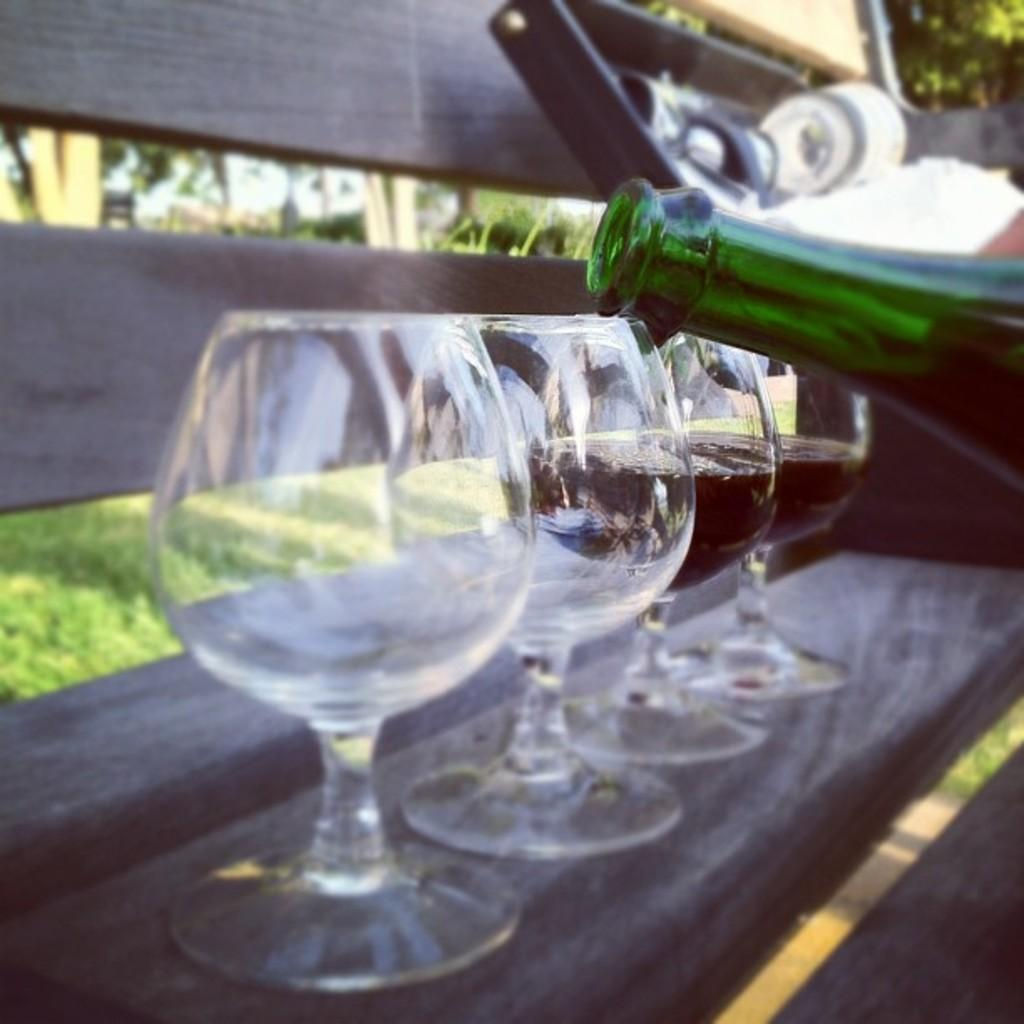What piece of furniture is present in the image? There is a table in the image. What is on the table? There is a glass with a drink and a bottle on the table. What can be seen in the background of the image? There are trees with green leaves in the background of the image. What type of vegetation is at the bottom of the image? There is grass at the bottom of the image. How many friends are sitting around the table in the image? There is no information about friends in the image; it only shows a table with a glass, a bottle, and a background with trees and grass. 